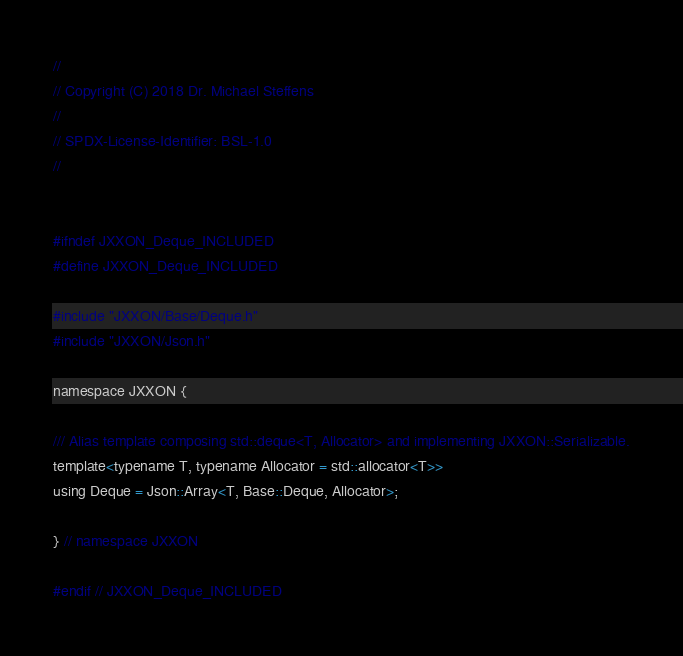<code> <loc_0><loc_0><loc_500><loc_500><_C_>//
// Copyright (C) 2018 Dr. Michael Steffens
//
// SPDX-License-Identifier:	BSL-1.0
//


#ifndef JXXON_Deque_INCLUDED
#define JXXON_Deque_INCLUDED

#include "JXXON/Base/Deque.h"
#include "JXXON/Json.h"

namespace JXXON {

/// Alias template composing std::deque<T, Allocator> and implementing JXXON::Serializable.
template<typename T, typename Allocator = std::allocator<T>>
using Deque = Json::Array<T, Base::Deque, Allocator>;

} // namespace JXXON

#endif // JXXON_Deque_INCLUDED
</code> 